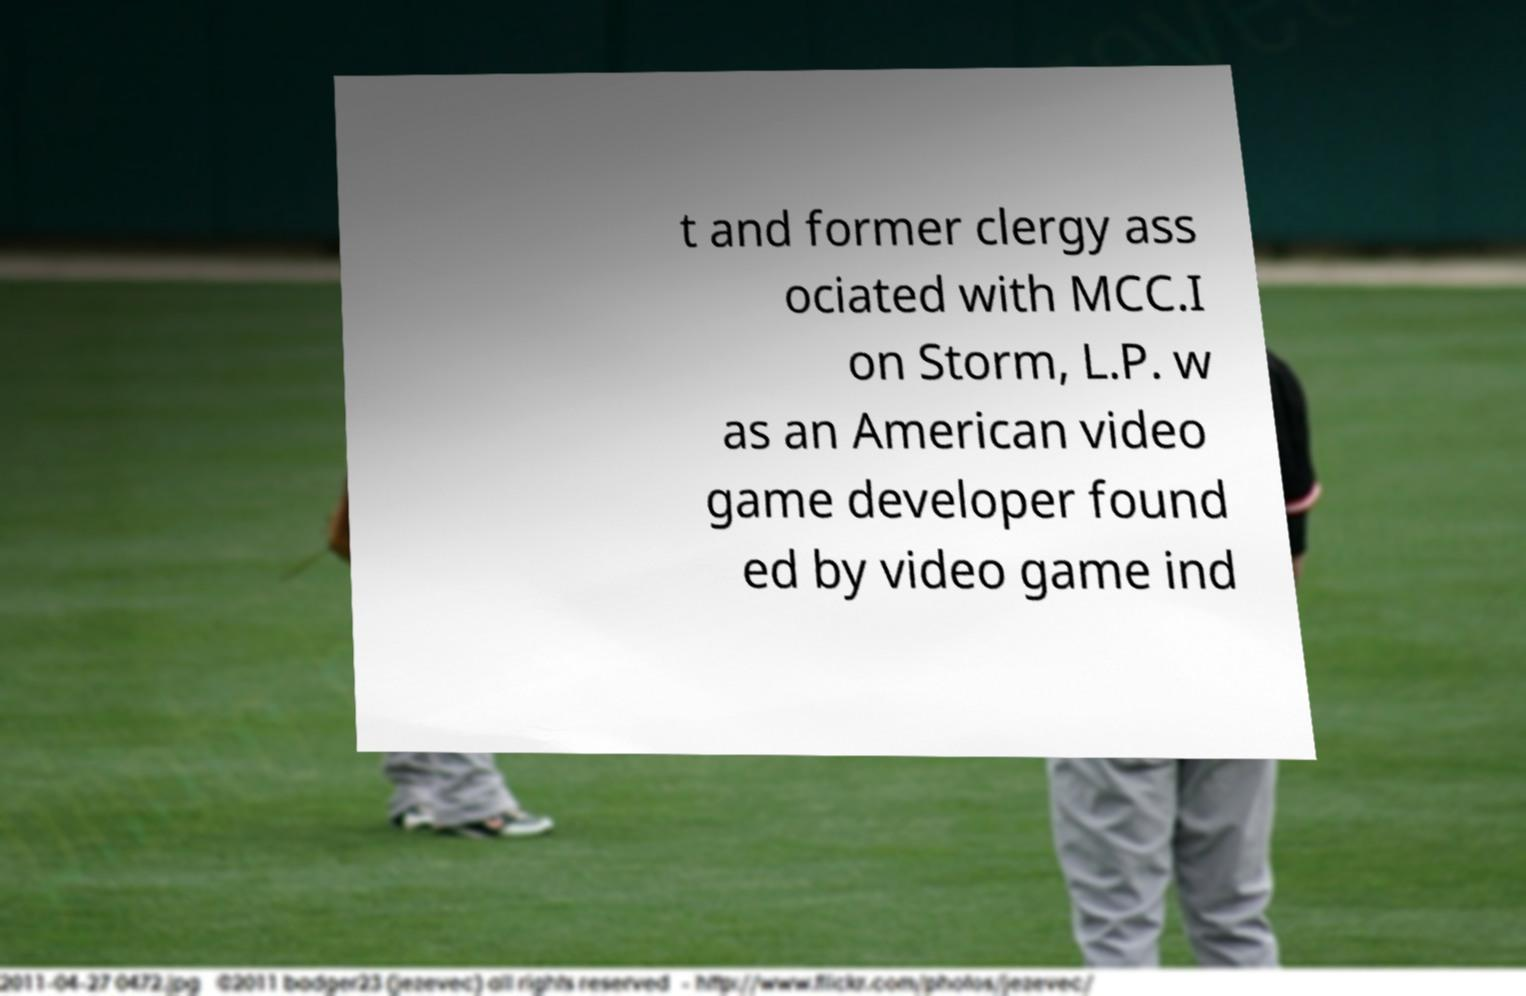Please identify and transcribe the text found in this image. t and former clergy ass ociated with MCC.I on Storm, L.P. w as an American video game developer found ed by video game ind 